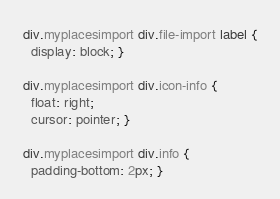<code> <loc_0><loc_0><loc_500><loc_500><_CSS_>div.myplacesimport div.file-import label {
  display: block; }

div.myplacesimport div.icon-info {
  float: right;
  cursor: pointer; }

div.myplacesimport div.info {
  padding-bottom: 2px; }
</code> 